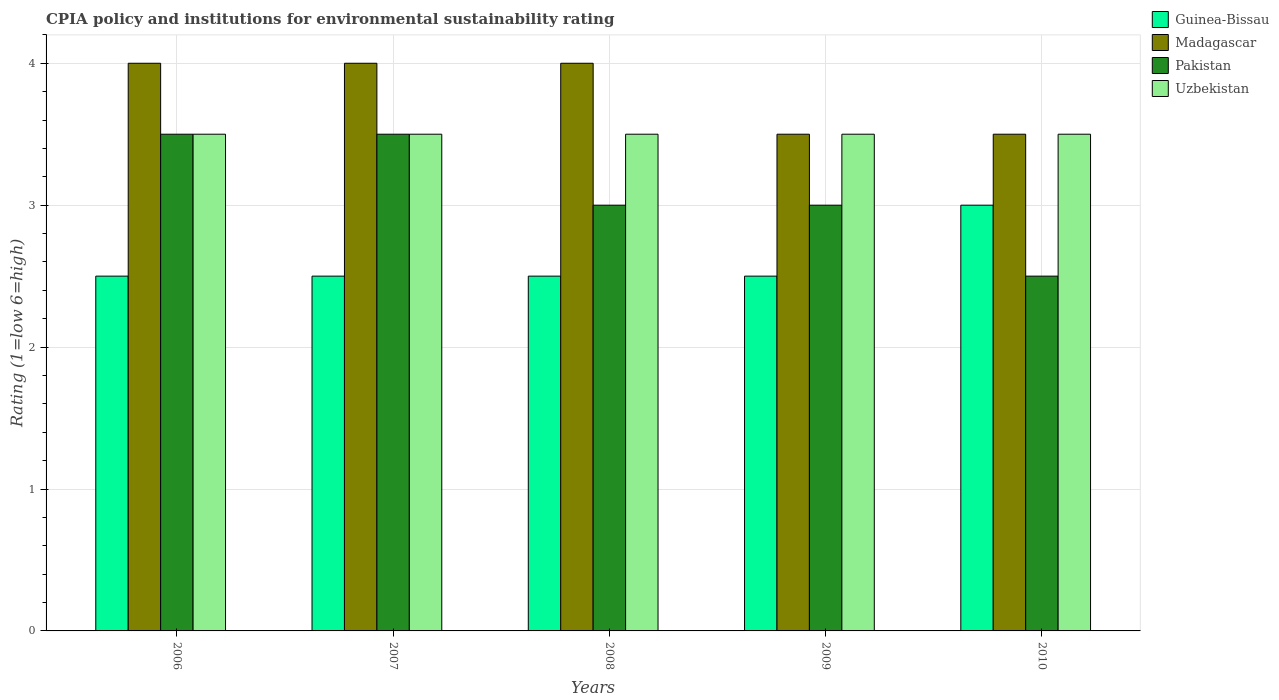How many different coloured bars are there?
Offer a terse response. 4. Are the number of bars per tick equal to the number of legend labels?
Your answer should be very brief. Yes. Are the number of bars on each tick of the X-axis equal?
Your answer should be compact. Yes. In how many cases, is the number of bars for a given year not equal to the number of legend labels?
Provide a short and direct response. 0. Across all years, what is the minimum CPIA rating in Madagascar?
Offer a very short reply. 3.5. In which year was the CPIA rating in Pakistan minimum?
Keep it short and to the point. 2010. What is the total CPIA rating in Guinea-Bissau in the graph?
Offer a very short reply. 13. What is the difference between the CPIA rating in Madagascar in 2007 and that in 2010?
Provide a short and direct response. 0.5. What is the average CPIA rating in Uzbekistan per year?
Make the answer very short. 3.5. In the year 2006, what is the difference between the CPIA rating in Uzbekistan and CPIA rating in Madagascar?
Your answer should be compact. -0.5. In how many years, is the CPIA rating in Guinea-Bissau greater than 2.4?
Give a very brief answer. 5. Is the CPIA rating in Madagascar in 2008 less than that in 2009?
Offer a terse response. No. Is the difference between the CPIA rating in Uzbekistan in 2007 and 2008 greater than the difference between the CPIA rating in Madagascar in 2007 and 2008?
Offer a terse response. No. What is the difference between the highest and the second highest CPIA rating in Madagascar?
Your answer should be compact. 0. What is the difference between the highest and the lowest CPIA rating in Pakistan?
Your response must be concise. 1. Is the sum of the CPIA rating in Madagascar in 2007 and 2009 greater than the maximum CPIA rating in Guinea-Bissau across all years?
Offer a very short reply. Yes. Is it the case that in every year, the sum of the CPIA rating in Pakistan and CPIA rating in Uzbekistan is greater than the sum of CPIA rating in Madagascar and CPIA rating in Guinea-Bissau?
Your answer should be very brief. No. What does the 2nd bar from the left in 2010 represents?
Your answer should be compact. Madagascar. What does the 1st bar from the right in 2008 represents?
Make the answer very short. Uzbekistan. How many years are there in the graph?
Ensure brevity in your answer.  5. What is the difference between two consecutive major ticks on the Y-axis?
Provide a succinct answer. 1. Does the graph contain any zero values?
Your answer should be compact. No. Where does the legend appear in the graph?
Give a very brief answer. Top right. How many legend labels are there?
Ensure brevity in your answer.  4. How are the legend labels stacked?
Ensure brevity in your answer.  Vertical. What is the title of the graph?
Give a very brief answer. CPIA policy and institutions for environmental sustainability rating. What is the label or title of the X-axis?
Your answer should be compact. Years. What is the label or title of the Y-axis?
Ensure brevity in your answer.  Rating (1=low 6=high). What is the Rating (1=low 6=high) of Guinea-Bissau in 2006?
Offer a terse response. 2.5. What is the Rating (1=low 6=high) in Madagascar in 2006?
Give a very brief answer. 4. What is the Rating (1=low 6=high) in Guinea-Bissau in 2007?
Ensure brevity in your answer.  2.5. What is the Rating (1=low 6=high) in Uzbekistan in 2007?
Ensure brevity in your answer.  3.5. What is the Rating (1=low 6=high) in Guinea-Bissau in 2008?
Your answer should be very brief. 2.5. What is the Rating (1=low 6=high) of Uzbekistan in 2008?
Offer a terse response. 3.5. What is the Rating (1=low 6=high) of Pakistan in 2009?
Your answer should be very brief. 3. What is the Rating (1=low 6=high) in Madagascar in 2010?
Your answer should be compact. 3.5. What is the Rating (1=low 6=high) of Uzbekistan in 2010?
Make the answer very short. 3.5. Across all years, what is the maximum Rating (1=low 6=high) of Madagascar?
Make the answer very short. 4. Across all years, what is the minimum Rating (1=low 6=high) of Guinea-Bissau?
Provide a short and direct response. 2.5. Across all years, what is the minimum Rating (1=low 6=high) of Madagascar?
Offer a very short reply. 3.5. Across all years, what is the minimum Rating (1=low 6=high) in Uzbekistan?
Keep it short and to the point. 3.5. What is the total Rating (1=low 6=high) of Guinea-Bissau in the graph?
Offer a very short reply. 13. What is the total Rating (1=low 6=high) of Madagascar in the graph?
Your answer should be compact. 19. What is the difference between the Rating (1=low 6=high) of Guinea-Bissau in 2006 and that in 2007?
Offer a terse response. 0. What is the difference between the Rating (1=low 6=high) in Madagascar in 2006 and that in 2007?
Make the answer very short. 0. What is the difference between the Rating (1=low 6=high) of Pakistan in 2006 and that in 2007?
Keep it short and to the point. 0. What is the difference between the Rating (1=low 6=high) in Guinea-Bissau in 2006 and that in 2009?
Offer a terse response. 0. What is the difference between the Rating (1=low 6=high) of Madagascar in 2006 and that in 2009?
Offer a terse response. 0.5. What is the difference between the Rating (1=low 6=high) in Pakistan in 2006 and that in 2009?
Your response must be concise. 0.5. What is the difference between the Rating (1=low 6=high) of Uzbekistan in 2006 and that in 2009?
Make the answer very short. 0. What is the difference between the Rating (1=low 6=high) in Madagascar in 2006 and that in 2010?
Provide a succinct answer. 0.5. What is the difference between the Rating (1=low 6=high) of Uzbekistan in 2006 and that in 2010?
Make the answer very short. 0. What is the difference between the Rating (1=low 6=high) of Guinea-Bissau in 2007 and that in 2008?
Your answer should be compact. 0. What is the difference between the Rating (1=low 6=high) of Madagascar in 2007 and that in 2008?
Your answer should be compact. 0. What is the difference between the Rating (1=low 6=high) of Pakistan in 2007 and that in 2008?
Provide a succinct answer. 0.5. What is the difference between the Rating (1=low 6=high) of Uzbekistan in 2007 and that in 2008?
Make the answer very short. 0. What is the difference between the Rating (1=low 6=high) in Uzbekistan in 2007 and that in 2009?
Ensure brevity in your answer.  0. What is the difference between the Rating (1=low 6=high) in Pakistan in 2007 and that in 2010?
Offer a very short reply. 1. What is the difference between the Rating (1=low 6=high) of Uzbekistan in 2007 and that in 2010?
Offer a terse response. 0. What is the difference between the Rating (1=low 6=high) in Guinea-Bissau in 2008 and that in 2009?
Keep it short and to the point. 0. What is the difference between the Rating (1=low 6=high) in Madagascar in 2008 and that in 2009?
Your answer should be compact. 0.5. What is the difference between the Rating (1=low 6=high) in Uzbekistan in 2008 and that in 2009?
Offer a terse response. 0. What is the difference between the Rating (1=low 6=high) in Guinea-Bissau in 2008 and that in 2010?
Make the answer very short. -0.5. What is the difference between the Rating (1=low 6=high) in Pakistan in 2008 and that in 2010?
Your response must be concise. 0.5. What is the difference between the Rating (1=low 6=high) of Uzbekistan in 2008 and that in 2010?
Give a very brief answer. 0. What is the difference between the Rating (1=low 6=high) of Guinea-Bissau in 2009 and that in 2010?
Your answer should be very brief. -0.5. What is the difference between the Rating (1=low 6=high) of Madagascar in 2009 and that in 2010?
Your answer should be compact. 0. What is the difference between the Rating (1=low 6=high) of Guinea-Bissau in 2006 and the Rating (1=low 6=high) of Pakistan in 2007?
Provide a short and direct response. -1. What is the difference between the Rating (1=low 6=high) of Guinea-Bissau in 2006 and the Rating (1=low 6=high) of Uzbekistan in 2007?
Keep it short and to the point. -1. What is the difference between the Rating (1=low 6=high) of Madagascar in 2006 and the Rating (1=low 6=high) of Uzbekistan in 2007?
Your answer should be very brief. 0.5. What is the difference between the Rating (1=low 6=high) in Guinea-Bissau in 2006 and the Rating (1=low 6=high) in Madagascar in 2008?
Offer a very short reply. -1.5. What is the difference between the Rating (1=low 6=high) in Guinea-Bissau in 2006 and the Rating (1=low 6=high) in Pakistan in 2008?
Your response must be concise. -0.5. What is the difference between the Rating (1=low 6=high) of Madagascar in 2006 and the Rating (1=low 6=high) of Pakistan in 2008?
Offer a terse response. 1. What is the difference between the Rating (1=low 6=high) of Pakistan in 2006 and the Rating (1=low 6=high) of Uzbekistan in 2008?
Ensure brevity in your answer.  0. What is the difference between the Rating (1=low 6=high) in Guinea-Bissau in 2006 and the Rating (1=low 6=high) in Madagascar in 2009?
Make the answer very short. -1. What is the difference between the Rating (1=low 6=high) in Guinea-Bissau in 2006 and the Rating (1=low 6=high) in Uzbekistan in 2009?
Provide a short and direct response. -1. What is the difference between the Rating (1=low 6=high) of Madagascar in 2006 and the Rating (1=low 6=high) of Uzbekistan in 2009?
Ensure brevity in your answer.  0.5. What is the difference between the Rating (1=low 6=high) in Guinea-Bissau in 2006 and the Rating (1=low 6=high) in Madagascar in 2010?
Your response must be concise. -1. What is the difference between the Rating (1=low 6=high) of Guinea-Bissau in 2006 and the Rating (1=low 6=high) of Pakistan in 2010?
Ensure brevity in your answer.  0. What is the difference between the Rating (1=low 6=high) in Guinea-Bissau in 2006 and the Rating (1=low 6=high) in Uzbekistan in 2010?
Your answer should be very brief. -1. What is the difference between the Rating (1=low 6=high) of Madagascar in 2006 and the Rating (1=low 6=high) of Uzbekistan in 2010?
Give a very brief answer. 0.5. What is the difference between the Rating (1=low 6=high) in Guinea-Bissau in 2007 and the Rating (1=low 6=high) in Madagascar in 2008?
Provide a succinct answer. -1.5. What is the difference between the Rating (1=low 6=high) in Madagascar in 2007 and the Rating (1=low 6=high) in Uzbekistan in 2008?
Offer a terse response. 0.5. What is the difference between the Rating (1=low 6=high) of Pakistan in 2007 and the Rating (1=low 6=high) of Uzbekistan in 2008?
Ensure brevity in your answer.  0. What is the difference between the Rating (1=low 6=high) in Guinea-Bissau in 2007 and the Rating (1=low 6=high) in Madagascar in 2009?
Offer a terse response. -1. What is the difference between the Rating (1=low 6=high) of Guinea-Bissau in 2007 and the Rating (1=low 6=high) of Uzbekistan in 2009?
Ensure brevity in your answer.  -1. What is the difference between the Rating (1=low 6=high) in Madagascar in 2007 and the Rating (1=low 6=high) in Uzbekistan in 2009?
Keep it short and to the point. 0.5. What is the difference between the Rating (1=low 6=high) in Guinea-Bissau in 2007 and the Rating (1=low 6=high) in Uzbekistan in 2010?
Keep it short and to the point. -1. What is the difference between the Rating (1=low 6=high) of Madagascar in 2007 and the Rating (1=low 6=high) of Uzbekistan in 2010?
Provide a short and direct response. 0.5. What is the difference between the Rating (1=low 6=high) in Guinea-Bissau in 2008 and the Rating (1=low 6=high) in Uzbekistan in 2009?
Your answer should be very brief. -1. What is the difference between the Rating (1=low 6=high) of Guinea-Bissau in 2008 and the Rating (1=low 6=high) of Madagascar in 2010?
Keep it short and to the point. -1. What is the difference between the Rating (1=low 6=high) of Guinea-Bissau in 2008 and the Rating (1=low 6=high) of Uzbekistan in 2010?
Offer a terse response. -1. What is the difference between the Rating (1=low 6=high) in Madagascar in 2008 and the Rating (1=low 6=high) in Pakistan in 2010?
Your answer should be very brief. 1.5. What is the difference between the Rating (1=low 6=high) in Madagascar in 2008 and the Rating (1=low 6=high) in Uzbekistan in 2010?
Keep it short and to the point. 0.5. What is the difference between the Rating (1=low 6=high) of Guinea-Bissau in 2009 and the Rating (1=low 6=high) of Pakistan in 2010?
Make the answer very short. 0. What is the difference between the Rating (1=low 6=high) of Madagascar in 2009 and the Rating (1=low 6=high) of Pakistan in 2010?
Your response must be concise. 1. What is the difference between the Rating (1=low 6=high) of Pakistan in 2009 and the Rating (1=low 6=high) of Uzbekistan in 2010?
Make the answer very short. -0.5. What is the average Rating (1=low 6=high) in Pakistan per year?
Provide a succinct answer. 3.1. In the year 2006, what is the difference between the Rating (1=low 6=high) in Guinea-Bissau and Rating (1=low 6=high) in Uzbekistan?
Your answer should be compact. -1. In the year 2006, what is the difference between the Rating (1=low 6=high) in Madagascar and Rating (1=low 6=high) in Pakistan?
Keep it short and to the point. 0.5. In the year 2007, what is the difference between the Rating (1=low 6=high) in Guinea-Bissau and Rating (1=low 6=high) in Madagascar?
Your response must be concise. -1.5. In the year 2007, what is the difference between the Rating (1=low 6=high) in Guinea-Bissau and Rating (1=low 6=high) in Uzbekistan?
Offer a very short reply. -1. In the year 2007, what is the difference between the Rating (1=low 6=high) of Madagascar and Rating (1=low 6=high) of Uzbekistan?
Your response must be concise. 0.5. In the year 2008, what is the difference between the Rating (1=low 6=high) of Guinea-Bissau and Rating (1=low 6=high) of Pakistan?
Your response must be concise. -0.5. In the year 2009, what is the difference between the Rating (1=low 6=high) in Guinea-Bissau and Rating (1=low 6=high) in Madagascar?
Your answer should be very brief. -1. In the year 2009, what is the difference between the Rating (1=low 6=high) of Guinea-Bissau and Rating (1=low 6=high) of Pakistan?
Make the answer very short. -0.5. In the year 2009, what is the difference between the Rating (1=low 6=high) in Guinea-Bissau and Rating (1=low 6=high) in Uzbekistan?
Make the answer very short. -1. In the year 2009, what is the difference between the Rating (1=low 6=high) in Madagascar and Rating (1=low 6=high) in Pakistan?
Make the answer very short. 0.5. In the year 2010, what is the difference between the Rating (1=low 6=high) of Guinea-Bissau and Rating (1=low 6=high) of Madagascar?
Provide a short and direct response. -0.5. In the year 2010, what is the difference between the Rating (1=low 6=high) of Madagascar and Rating (1=low 6=high) of Pakistan?
Your answer should be compact. 1. In the year 2010, what is the difference between the Rating (1=low 6=high) of Pakistan and Rating (1=low 6=high) of Uzbekistan?
Your response must be concise. -1. What is the ratio of the Rating (1=low 6=high) in Pakistan in 2006 to that in 2007?
Offer a terse response. 1. What is the ratio of the Rating (1=low 6=high) in Pakistan in 2006 to that in 2008?
Offer a terse response. 1.17. What is the ratio of the Rating (1=low 6=high) of Guinea-Bissau in 2006 to that in 2009?
Provide a short and direct response. 1. What is the ratio of the Rating (1=low 6=high) in Pakistan in 2006 to that in 2009?
Provide a short and direct response. 1.17. What is the ratio of the Rating (1=low 6=high) of Madagascar in 2007 to that in 2009?
Provide a short and direct response. 1.14. What is the ratio of the Rating (1=low 6=high) in Uzbekistan in 2007 to that in 2009?
Offer a very short reply. 1. What is the ratio of the Rating (1=low 6=high) in Guinea-Bissau in 2007 to that in 2010?
Keep it short and to the point. 0.83. What is the ratio of the Rating (1=low 6=high) in Madagascar in 2007 to that in 2010?
Provide a short and direct response. 1.14. What is the ratio of the Rating (1=low 6=high) in Pakistan in 2007 to that in 2010?
Your answer should be compact. 1.4. What is the ratio of the Rating (1=low 6=high) of Guinea-Bissau in 2008 to that in 2009?
Provide a succinct answer. 1. What is the ratio of the Rating (1=low 6=high) of Madagascar in 2008 to that in 2010?
Make the answer very short. 1.14. What is the ratio of the Rating (1=low 6=high) of Uzbekistan in 2008 to that in 2010?
Your answer should be compact. 1. What is the ratio of the Rating (1=low 6=high) of Guinea-Bissau in 2009 to that in 2010?
Provide a short and direct response. 0.83. What is the ratio of the Rating (1=low 6=high) of Madagascar in 2009 to that in 2010?
Make the answer very short. 1. What is the ratio of the Rating (1=low 6=high) in Uzbekistan in 2009 to that in 2010?
Keep it short and to the point. 1. What is the difference between the highest and the second highest Rating (1=low 6=high) in Guinea-Bissau?
Your answer should be very brief. 0.5. What is the difference between the highest and the second highest Rating (1=low 6=high) in Madagascar?
Provide a succinct answer. 0. What is the difference between the highest and the second highest Rating (1=low 6=high) of Pakistan?
Make the answer very short. 0. What is the difference between the highest and the second highest Rating (1=low 6=high) in Uzbekistan?
Offer a terse response. 0. What is the difference between the highest and the lowest Rating (1=low 6=high) in Madagascar?
Provide a short and direct response. 0.5. What is the difference between the highest and the lowest Rating (1=low 6=high) of Pakistan?
Offer a terse response. 1. What is the difference between the highest and the lowest Rating (1=low 6=high) in Uzbekistan?
Your answer should be very brief. 0. 